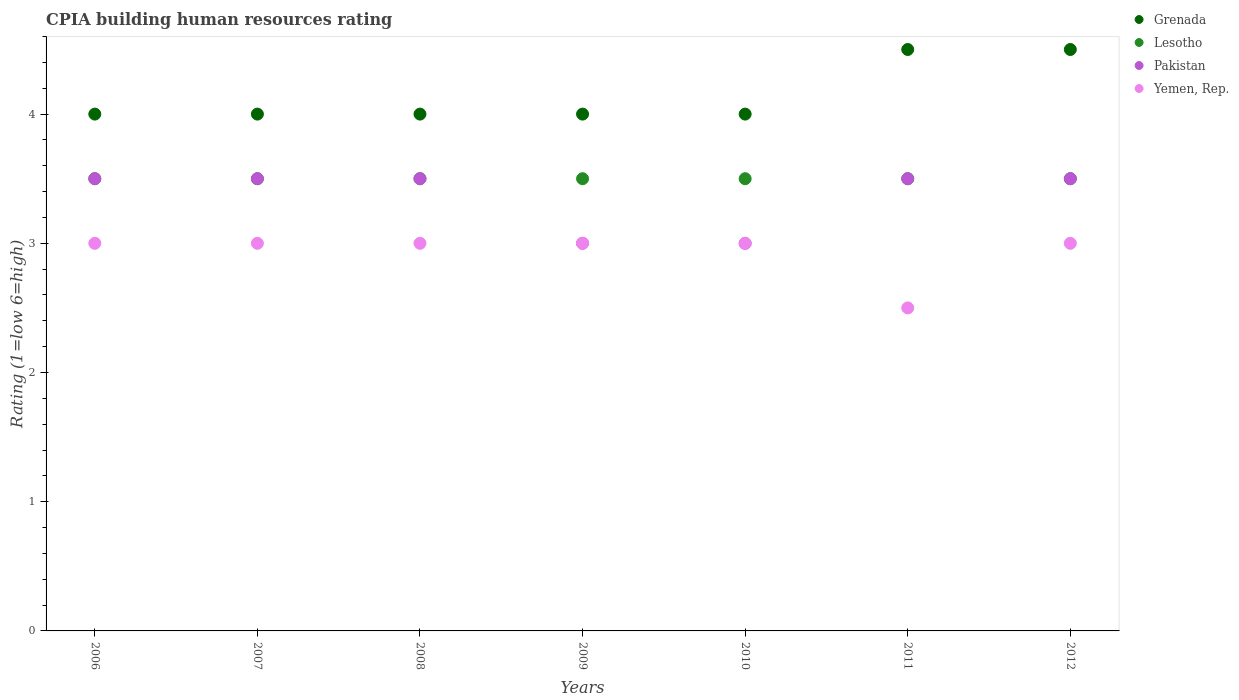How many different coloured dotlines are there?
Your answer should be very brief. 4. Across all years, what is the maximum CPIA rating in Grenada?
Keep it short and to the point. 4.5. In which year was the CPIA rating in Pakistan minimum?
Offer a very short reply. 2009. What is the total CPIA rating in Yemen, Rep. in the graph?
Your answer should be very brief. 20.5. What is the difference between the CPIA rating in Yemen, Rep. in 2009 and that in 2011?
Your answer should be compact. 0.5. What is the average CPIA rating in Pakistan per year?
Your answer should be very brief. 3.36. In the year 2010, what is the difference between the CPIA rating in Lesotho and CPIA rating in Grenada?
Give a very brief answer. -0.5. In how many years, is the CPIA rating in Lesotho greater than 4.4?
Keep it short and to the point. 0. What is the ratio of the CPIA rating in Pakistan in 2006 to that in 2007?
Provide a succinct answer. 1. Is the difference between the CPIA rating in Lesotho in 2008 and 2009 greater than the difference between the CPIA rating in Grenada in 2008 and 2009?
Your response must be concise. No. What is the difference between the highest and the second highest CPIA rating in Grenada?
Your answer should be very brief. 0. What is the difference between the highest and the lowest CPIA rating in Yemen, Rep.?
Give a very brief answer. 0.5. In how many years, is the CPIA rating in Yemen, Rep. greater than the average CPIA rating in Yemen, Rep. taken over all years?
Your answer should be very brief. 6. Is it the case that in every year, the sum of the CPIA rating in Lesotho and CPIA rating in Yemen, Rep.  is greater than the sum of CPIA rating in Grenada and CPIA rating in Pakistan?
Provide a succinct answer. No. Is it the case that in every year, the sum of the CPIA rating in Yemen, Rep. and CPIA rating in Lesotho  is greater than the CPIA rating in Pakistan?
Ensure brevity in your answer.  Yes. How many dotlines are there?
Provide a short and direct response. 4. What is the difference between two consecutive major ticks on the Y-axis?
Ensure brevity in your answer.  1. Are the values on the major ticks of Y-axis written in scientific E-notation?
Offer a terse response. No. Does the graph contain any zero values?
Ensure brevity in your answer.  No. Where does the legend appear in the graph?
Your response must be concise. Top right. How are the legend labels stacked?
Offer a terse response. Vertical. What is the title of the graph?
Provide a succinct answer. CPIA building human resources rating. Does "Montenegro" appear as one of the legend labels in the graph?
Keep it short and to the point. No. What is the label or title of the X-axis?
Your answer should be very brief. Years. What is the label or title of the Y-axis?
Your response must be concise. Rating (1=low 6=high). What is the Rating (1=low 6=high) of Pakistan in 2007?
Your response must be concise. 3.5. What is the Rating (1=low 6=high) in Lesotho in 2008?
Ensure brevity in your answer.  3.5. What is the Rating (1=low 6=high) of Pakistan in 2008?
Make the answer very short. 3.5. What is the Rating (1=low 6=high) in Grenada in 2009?
Your answer should be very brief. 4. What is the Rating (1=low 6=high) in Grenada in 2010?
Offer a terse response. 4. What is the Rating (1=low 6=high) of Yemen, Rep. in 2011?
Offer a very short reply. 2.5. What is the Rating (1=low 6=high) of Lesotho in 2012?
Offer a very short reply. 3.5. What is the Rating (1=low 6=high) of Yemen, Rep. in 2012?
Provide a succinct answer. 3. Across all years, what is the maximum Rating (1=low 6=high) of Lesotho?
Offer a very short reply. 3.5. Across all years, what is the minimum Rating (1=low 6=high) in Lesotho?
Keep it short and to the point. 3.5. Across all years, what is the minimum Rating (1=low 6=high) of Yemen, Rep.?
Offer a terse response. 2.5. What is the total Rating (1=low 6=high) in Grenada in the graph?
Ensure brevity in your answer.  29. What is the total Rating (1=low 6=high) of Pakistan in the graph?
Your response must be concise. 23.5. What is the difference between the Rating (1=low 6=high) of Lesotho in 2006 and that in 2007?
Offer a terse response. 0. What is the difference between the Rating (1=low 6=high) in Grenada in 2006 and that in 2008?
Your answer should be very brief. 0. What is the difference between the Rating (1=low 6=high) of Lesotho in 2006 and that in 2008?
Offer a very short reply. 0. What is the difference between the Rating (1=low 6=high) in Pakistan in 2006 and that in 2008?
Provide a succinct answer. 0. What is the difference between the Rating (1=low 6=high) in Lesotho in 2006 and that in 2009?
Offer a terse response. 0. What is the difference between the Rating (1=low 6=high) in Pakistan in 2006 and that in 2009?
Your answer should be very brief. 0.5. What is the difference between the Rating (1=low 6=high) of Yemen, Rep. in 2006 and that in 2009?
Offer a very short reply. 0. What is the difference between the Rating (1=low 6=high) of Lesotho in 2006 and that in 2010?
Your answer should be very brief. 0. What is the difference between the Rating (1=low 6=high) in Pakistan in 2006 and that in 2010?
Your answer should be compact. 0.5. What is the difference between the Rating (1=low 6=high) in Pakistan in 2006 and that in 2011?
Offer a very short reply. 0. What is the difference between the Rating (1=low 6=high) of Lesotho in 2006 and that in 2012?
Provide a succinct answer. 0. What is the difference between the Rating (1=low 6=high) of Pakistan in 2007 and that in 2008?
Your answer should be very brief. 0. What is the difference between the Rating (1=low 6=high) of Yemen, Rep. in 2007 and that in 2008?
Ensure brevity in your answer.  0. What is the difference between the Rating (1=low 6=high) of Yemen, Rep. in 2007 and that in 2010?
Keep it short and to the point. 0. What is the difference between the Rating (1=low 6=high) of Grenada in 2007 and that in 2011?
Provide a succinct answer. -0.5. What is the difference between the Rating (1=low 6=high) in Pakistan in 2007 and that in 2011?
Give a very brief answer. 0. What is the difference between the Rating (1=low 6=high) in Yemen, Rep. in 2007 and that in 2011?
Offer a terse response. 0.5. What is the difference between the Rating (1=low 6=high) of Grenada in 2007 and that in 2012?
Offer a terse response. -0.5. What is the difference between the Rating (1=low 6=high) of Lesotho in 2007 and that in 2012?
Offer a terse response. 0. What is the difference between the Rating (1=low 6=high) in Grenada in 2008 and that in 2009?
Your answer should be compact. 0. What is the difference between the Rating (1=low 6=high) in Pakistan in 2008 and that in 2011?
Provide a short and direct response. 0. What is the difference between the Rating (1=low 6=high) of Yemen, Rep. in 2008 and that in 2011?
Ensure brevity in your answer.  0.5. What is the difference between the Rating (1=low 6=high) in Lesotho in 2008 and that in 2012?
Keep it short and to the point. 0. What is the difference between the Rating (1=low 6=high) in Pakistan in 2008 and that in 2012?
Offer a very short reply. 0. What is the difference between the Rating (1=low 6=high) in Grenada in 2009 and that in 2010?
Offer a terse response. 0. What is the difference between the Rating (1=low 6=high) of Grenada in 2009 and that in 2011?
Provide a succinct answer. -0.5. What is the difference between the Rating (1=low 6=high) in Grenada in 2009 and that in 2012?
Offer a terse response. -0.5. What is the difference between the Rating (1=low 6=high) in Grenada in 2010 and that in 2011?
Provide a short and direct response. -0.5. What is the difference between the Rating (1=low 6=high) of Lesotho in 2010 and that in 2011?
Offer a very short reply. 0. What is the difference between the Rating (1=low 6=high) of Pakistan in 2010 and that in 2011?
Keep it short and to the point. -0.5. What is the difference between the Rating (1=low 6=high) in Yemen, Rep. in 2010 and that in 2011?
Offer a very short reply. 0.5. What is the difference between the Rating (1=low 6=high) in Grenada in 2010 and that in 2012?
Offer a very short reply. -0.5. What is the difference between the Rating (1=low 6=high) in Pakistan in 2010 and that in 2012?
Your answer should be compact. -0.5. What is the difference between the Rating (1=low 6=high) in Lesotho in 2011 and that in 2012?
Your answer should be compact. 0. What is the difference between the Rating (1=low 6=high) of Yemen, Rep. in 2011 and that in 2012?
Keep it short and to the point. -0.5. What is the difference between the Rating (1=low 6=high) of Grenada in 2006 and the Rating (1=low 6=high) of Lesotho in 2007?
Provide a succinct answer. 0.5. What is the difference between the Rating (1=low 6=high) in Lesotho in 2006 and the Rating (1=low 6=high) in Yemen, Rep. in 2007?
Make the answer very short. 0.5. What is the difference between the Rating (1=low 6=high) in Pakistan in 2006 and the Rating (1=low 6=high) in Yemen, Rep. in 2007?
Provide a succinct answer. 0.5. What is the difference between the Rating (1=low 6=high) of Grenada in 2006 and the Rating (1=low 6=high) of Lesotho in 2008?
Offer a terse response. 0.5. What is the difference between the Rating (1=low 6=high) of Lesotho in 2006 and the Rating (1=low 6=high) of Pakistan in 2008?
Ensure brevity in your answer.  0. What is the difference between the Rating (1=low 6=high) of Lesotho in 2006 and the Rating (1=low 6=high) of Yemen, Rep. in 2008?
Your answer should be very brief. 0.5. What is the difference between the Rating (1=low 6=high) in Pakistan in 2006 and the Rating (1=low 6=high) in Yemen, Rep. in 2008?
Your answer should be very brief. 0.5. What is the difference between the Rating (1=low 6=high) of Lesotho in 2006 and the Rating (1=low 6=high) of Pakistan in 2009?
Your answer should be very brief. 0.5. What is the difference between the Rating (1=low 6=high) of Grenada in 2006 and the Rating (1=low 6=high) of Lesotho in 2010?
Your response must be concise. 0.5. What is the difference between the Rating (1=low 6=high) in Lesotho in 2006 and the Rating (1=low 6=high) in Yemen, Rep. in 2010?
Offer a terse response. 0.5. What is the difference between the Rating (1=low 6=high) of Lesotho in 2006 and the Rating (1=low 6=high) of Yemen, Rep. in 2011?
Keep it short and to the point. 1. What is the difference between the Rating (1=low 6=high) of Grenada in 2006 and the Rating (1=low 6=high) of Pakistan in 2012?
Your answer should be compact. 0.5. What is the difference between the Rating (1=low 6=high) of Lesotho in 2006 and the Rating (1=low 6=high) of Pakistan in 2012?
Offer a terse response. 0. What is the difference between the Rating (1=low 6=high) of Lesotho in 2006 and the Rating (1=low 6=high) of Yemen, Rep. in 2012?
Provide a short and direct response. 0.5. What is the difference between the Rating (1=low 6=high) in Pakistan in 2006 and the Rating (1=low 6=high) in Yemen, Rep. in 2012?
Provide a succinct answer. 0.5. What is the difference between the Rating (1=low 6=high) in Grenada in 2007 and the Rating (1=low 6=high) in Pakistan in 2008?
Keep it short and to the point. 0.5. What is the difference between the Rating (1=low 6=high) of Grenada in 2007 and the Rating (1=low 6=high) of Yemen, Rep. in 2008?
Give a very brief answer. 1. What is the difference between the Rating (1=low 6=high) of Grenada in 2007 and the Rating (1=low 6=high) of Lesotho in 2009?
Give a very brief answer. 0.5. What is the difference between the Rating (1=low 6=high) in Grenada in 2007 and the Rating (1=low 6=high) in Yemen, Rep. in 2009?
Your answer should be compact. 1. What is the difference between the Rating (1=low 6=high) of Lesotho in 2007 and the Rating (1=low 6=high) of Pakistan in 2009?
Offer a terse response. 0.5. What is the difference between the Rating (1=low 6=high) in Lesotho in 2007 and the Rating (1=low 6=high) in Yemen, Rep. in 2009?
Offer a terse response. 0.5. What is the difference between the Rating (1=low 6=high) in Pakistan in 2007 and the Rating (1=low 6=high) in Yemen, Rep. in 2009?
Your answer should be compact. 0.5. What is the difference between the Rating (1=low 6=high) in Grenada in 2007 and the Rating (1=low 6=high) in Lesotho in 2010?
Provide a succinct answer. 0.5. What is the difference between the Rating (1=low 6=high) of Grenada in 2007 and the Rating (1=low 6=high) of Pakistan in 2010?
Your answer should be very brief. 1. What is the difference between the Rating (1=low 6=high) in Lesotho in 2007 and the Rating (1=low 6=high) in Pakistan in 2010?
Offer a terse response. 0.5. What is the difference between the Rating (1=low 6=high) in Grenada in 2007 and the Rating (1=low 6=high) in Lesotho in 2011?
Offer a terse response. 0.5. What is the difference between the Rating (1=low 6=high) of Grenada in 2007 and the Rating (1=low 6=high) of Pakistan in 2011?
Your answer should be very brief. 0.5. What is the difference between the Rating (1=low 6=high) in Lesotho in 2007 and the Rating (1=low 6=high) in Yemen, Rep. in 2011?
Provide a short and direct response. 1. What is the difference between the Rating (1=low 6=high) in Pakistan in 2007 and the Rating (1=low 6=high) in Yemen, Rep. in 2011?
Ensure brevity in your answer.  1. What is the difference between the Rating (1=low 6=high) of Grenada in 2007 and the Rating (1=low 6=high) of Lesotho in 2012?
Your answer should be compact. 0.5. What is the difference between the Rating (1=low 6=high) in Grenada in 2007 and the Rating (1=low 6=high) in Pakistan in 2012?
Give a very brief answer. 0.5. What is the difference between the Rating (1=low 6=high) of Lesotho in 2007 and the Rating (1=low 6=high) of Pakistan in 2012?
Offer a very short reply. 0. What is the difference between the Rating (1=low 6=high) in Lesotho in 2007 and the Rating (1=low 6=high) in Yemen, Rep. in 2012?
Make the answer very short. 0.5. What is the difference between the Rating (1=low 6=high) in Pakistan in 2007 and the Rating (1=low 6=high) in Yemen, Rep. in 2012?
Provide a short and direct response. 0.5. What is the difference between the Rating (1=low 6=high) of Grenada in 2008 and the Rating (1=low 6=high) of Pakistan in 2009?
Offer a terse response. 1. What is the difference between the Rating (1=low 6=high) of Lesotho in 2008 and the Rating (1=low 6=high) of Yemen, Rep. in 2010?
Give a very brief answer. 0.5. What is the difference between the Rating (1=low 6=high) in Pakistan in 2008 and the Rating (1=low 6=high) in Yemen, Rep. in 2010?
Offer a very short reply. 0.5. What is the difference between the Rating (1=low 6=high) in Grenada in 2008 and the Rating (1=low 6=high) in Pakistan in 2011?
Make the answer very short. 0.5. What is the difference between the Rating (1=low 6=high) of Grenada in 2008 and the Rating (1=low 6=high) of Lesotho in 2012?
Offer a terse response. 0.5. What is the difference between the Rating (1=low 6=high) of Grenada in 2008 and the Rating (1=low 6=high) of Pakistan in 2012?
Keep it short and to the point. 0.5. What is the difference between the Rating (1=low 6=high) of Grenada in 2008 and the Rating (1=low 6=high) of Yemen, Rep. in 2012?
Offer a terse response. 1. What is the difference between the Rating (1=low 6=high) of Lesotho in 2008 and the Rating (1=low 6=high) of Pakistan in 2012?
Keep it short and to the point. 0. What is the difference between the Rating (1=low 6=high) in Lesotho in 2008 and the Rating (1=low 6=high) in Yemen, Rep. in 2012?
Ensure brevity in your answer.  0.5. What is the difference between the Rating (1=low 6=high) of Pakistan in 2008 and the Rating (1=low 6=high) of Yemen, Rep. in 2012?
Provide a short and direct response. 0.5. What is the difference between the Rating (1=low 6=high) of Grenada in 2009 and the Rating (1=low 6=high) of Pakistan in 2010?
Give a very brief answer. 1. What is the difference between the Rating (1=low 6=high) of Lesotho in 2009 and the Rating (1=low 6=high) of Yemen, Rep. in 2010?
Provide a succinct answer. 0.5. What is the difference between the Rating (1=low 6=high) of Pakistan in 2009 and the Rating (1=low 6=high) of Yemen, Rep. in 2010?
Your answer should be compact. 0. What is the difference between the Rating (1=low 6=high) in Grenada in 2009 and the Rating (1=low 6=high) in Lesotho in 2011?
Your answer should be compact. 0.5. What is the difference between the Rating (1=low 6=high) in Grenada in 2009 and the Rating (1=low 6=high) in Pakistan in 2011?
Provide a short and direct response. 0.5. What is the difference between the Rating (1=low 6=high) in Grenada in 2009 and the Rating (1=low 6=high) in Yemen, Rep. in 2011?
Your response must be concise. 1.5. What is the difference between the Rating (1=low 6=high) of Lesotho in 2009 and the Rating (1=low 6=high) of Pakistan in 2011?
Make the answer very short. 0. What is the difference between the Rating (1=low 6=high) of Lesotho in 2009 and the Rating (1=low 6=high) of Yemen, Rep. in 2011?
Your answer should be very brief. 1. What is the difference between the Rating (1=low 6=high) of Pakistan in 2009 and the Rating (1=low 6=high) of Yemen, Rep. in 2011?
Ensure brevity in your answer.  0.5. What is the difference between the Rating (1=low 6=high) of Grenada in 2009 and the Rating (1=low 6=high) of Lesotho in 2012?
Provide a short and direct response. 0.5. What is the difference between the Rating (1=low 6=high) of Lesotho in 2009 and the Rating (1=low 6=high) of Yemen, Rep. in 2012?
Make the answer very short. 0.5. What is the difference between the Rating (1=low 6=high) in Grenada in 2010 and the Rating (1=low 6=high) in Pakistan in 2011?
Make the answer very short. 0.5. What is the difference between the Rating (1=low 6=high) in Lesotho in 2010 and the Rating (1=low 6=high) in Pakistan in 2011?
Provide a short and direct response. 0. What is the difference between the Rating (1=low 6=high) in Grenada in 2010 and the Rating (1=low 6=high) in Lesotho in 2012?
Give a very brief answer. 0.5. What is the difference between the Rating (1=low 6=high) of Grenada in 2010 and the Rating (1=low 6=high) of Yemen, Rep. in 2012?
Ensure brevity in your answer.  1. What is the difference between the Rating (1=low 6=high) of Grenada in 2011 and the Rating (1=low 6=high) of Lesotho in 2012?
Give a very brief answer. 1. What is the difference between the Rating (1=low 6=high) in Grenada in 2011 and the Rating (1=low 6=high) in Yemen, Rep. in 2012?
Ensure brevity in your answer.  1.5. What is the difference between the Rating (1=low 6=high) of Lesotho in 2011 and the Rating (1=low 6=high) of Pakistan in 2012?
Keep it short and to the point. 0. What is the average Rating (1=low 6=high) of Grenada per year?
Your response must be concise. 4.14. What is the average Rating (1=low 6=high) of Pakistan per year?
Make the answer very short. 3.36. What is the average Rating (1=low 6=high) in Yemen, Rep. per year?
Your response must be concise. 2.93. In the year 2006, what is the difference between the Rating (1=low 6=high) of Grenada and Rating (1=low 6=high) of Lesotho?
Your response must be concise. 0.5. In the year 2006, what is the difference between the Rating (1=low 6=high) in Lesotho and Rating (1=low 6=high) in Pakistan?
Offer a terse response. 0. In the year 2006, what is the difference between the Rating (1=low 6=high) of Pakistan and Rating (1=low 6=high) of Yemen, Rep.?
Give a very brief answer. 0.5. In the year 2007, what is the difference between the Rating (1=low 6=high) in Grenada and Rating (1=low 6=high) in Lesotho?
Ensure brevity in your answer.  0.5. In the year 2007, what is the difference between the Rating (1=low 6=high) of Grenada and Rating (1=low 6=high) of Pakistan?
Your answer should be compact. 0.5. In the year 2007, what is the difference between the Rating (1=low 6=high) in Lesotho and Rating (1=low 6=high) in Pakistan?
Make the answer very short. 0. In the year 2007, what is the difference between the Rating (1=low 6=high) of Lesotho and Rating (1=low 6=high) of Yemen, Rep.?
Provide a short and direct response. 0.5. In the year 2007, what is the difference between the Rating (1=low 6=high) in Pakistan and Rating (1=low 6=high) in Yemen, Rep.?
Ensure brevity in your answer.  0.5. In the year 2008, what is the difference between the Rating (1=low 6=high) of Lesotho and Rating (1=low 6=high) of Pakistan?
Offer a terse response. 0. In the year 2008, what is the difference between the Rating (1=low 6=high) of Lesotho and Rating (1=low 6=high) of Yemen, Rep.?
Your response must be concise. 0.5. In the year 2008, what is the difference between the Rating (1=low 6=high) in Pakistan and Rating (1=low 6=high) in Yemen, Rep.?
Provide a short and direct response. 0.5. In the year 2009, what is the difference between the Rating (1=low 6=high) of Grenada and Rating (1=low 6=high) of Yemen, Rep.?
Give a very brief answer. 1. In the year 2010, what is the difference between the Rating (1=low 6=high) in Grenada and Rating (1=low 6=high) in Lesotho?
Your answer should be compact. 0.5. In the year 2010, what is the difference between the Rating (1=low 6=high) in Lesotho and Rating (1=low 6=high) in Pakistan?
Offer a terse response. 0.5. In the year 2010, what is the difference between the Rating (1=low 6=high) in Lesotho and Rating (1=low 6=high) in Yemen, Rep.?
Provide a short and direct response. 0.5. In the year 2010, what is the difference between the Rating (1=low 6=high) in Pakistan and Rating (1=low 6=high) in Yemen, Rep.?
Ensure brevity in your answer.  0. In the year 2011, what is the difference between the Rating (1=low 6=high) in Grenada and Rating (1=low 6=high) in Pakistan?
Your answer should be very brief. 1. In the year 2011, what is the difference between the Rating (1=low 6=high) in Grenada and Rating (1=low 6=high) in Yemen, Rep.?
Make the answer very short. 2. In the year 2011, what is the difference between the Rating (1=low 6=high) of Lesotho and Rating (1=low 6=high) of Yemen, Rep.?
Your response must be concise. 1. In the year 2011, what is the difference between the Rating (1=low 6=high) of Pakistan and Rating (1=low 6=high) of Yemen, Rep.?
Make the answer very short. 1. In the year 2012, what is the difference between the Rating (1=low 6=high) of Grenada and Rating (1=low 6=high) of Pakistan?
Keep it short and to the point. 1. In the year 2012, what is the difference between the Rating (1=low 6=high) in Grenada and Rating (1=low 6=high) in Yemen, Rep.?
Ensure brevity in your answer.  1.5. What is the ratio of the Rating (1=low 6=high) in Lesotho in 2006 to that in 2007?
Your answer should be very brief. 1. What is the ratio of the Rating (1=low 6=high) of Lesotho in 2006 to that in 2008?
Your response must be concise. 1. What is the ratio of the Rating (1=low 6=high) of Yemen, Rep. in 2006 to that in 2008?
Provide a succinct answer. 1. What is the ratio of the Rating (1=low 6=high) of Grenada in 2006 to that in 2009?
Your answer should be very brief. 1. What is the ratio of the Rating (1=low 6=high) of Lesotho in 2006 to that in 2009?
Make the answer very short. 1. What is the ratio of the Rating (1=low 6=high) of Yemen, Rep. in 2006 to that in 2009?
Provide a succinct answer. 1. What is the ratio of the Rating (1=low 6=high) of Grenada in 2006 to that in 2010?
Provide a succinct answer. 1. What is the ratio of the Rating (1=low 6=high) of Pakistan in 2006 to that in 2010?
Your response must be concise. 1.17. What is the ratio of the Rating (1=low 6=high) of Yemen, Rep. in 2006 to that in 2010?
Make the answer very short. 1. What is the ratio of the Rating (1=low 6=high) of Lesotho in 2006 to that in 2011?
Ensure brevity in your answer.  1. What is the ratio of the Rating (1=low 6=high) of Grenada in 2006 to that in 2012?
Offer a very short reply. 0.89. What is the ratio of the Rating (1=low 6=high) in Pakistan in 2006 to that in 2012?
Ensure brevity in your answer.  1. What is the ratio of the Rating (1=low 6=high) of Yemen, Rep. in 2006 to that in 2012?
Give a very brief answer. 1. What is the ratio of the Rating (1=low 6=high) of Lesotho in 2007 to that in 2008?
Offer a very short reply. 1. What is the ratio of the Rating (1=low 6=high) of Pakistan in 2007 to that in 2008?
Provide a short and direct response. 1. What is the ratio of the Rating (1=low 6=high) of Yemen, Rep. in 2007 to that in 2008?
Your answer should be compact. 1. What is the ratio of the Rating (1=low 6=high) of Lesotho in 2007 to that in 2009?
Offer a very short reply. 1. What is the ratio of the Rating (1=low 6=high) of Pakistan in 2007 to that in 2009?
Ensure brevity in your answer.  1.17. What is the ratio of the Rating (1=low 6=high) of Yemen, Rep. in 2007 to that in 2009?
Ensure brevity in your answer.  1. What is the ratio of the Rating (1=low 6=high) in Lesotho in 2007 to that in 2010?
Offer a very short reply. 1. What is the ratio of the Rating (1=low 6=high) in Lesotho in 2007 to that in 2011?
Offer a terse response. 1. What is the ratio of the Rating (1=low 6=high) of Pakistan in 2007 to that in 2011?
Offer a very short reply. 1. What is the ratio of the Rating (1=low 6=high) in Yemen, Rep. in 2007 to that in 2011?
Your answer should be very brief. 1.2. What is the ratio of the Rating (1=low 6=high) of Grenada in 2007 to that in 2012?
Your answer should be compact. 0.89. What is the ratio of the Rating (1=low 6=high) of Pakistan in 2007 to that in 2012?
Keep it short and to the point. 1. What is the ratio of the Rating (1=low 6=high) in Lesotho in 2008 to that in 2009?
Provide a short and direct response. 1. What is the ratio of the Rating (1=low 6=high) in Yemen, Rep. in 2008 to that in 2009?
Your response must be concise. 1. What is the ratio of the Rating (1=low 6=high) of Lesotho in 2008 to that in 2010?
Your answer should be compact. 1. What is the ratio of the Rating (1=low 6=high) in Yemen, Rep. in 2008 to that in 2010?
Keep it short and to the point. 1. What is the ratio of the Rating (1=low 6=high) of Lesotho in 2008 to that in 2011?
Make the answer very short. 1. What is the ratio of the Rating (1=low 6=high) in Pakistan in 2008 to that in 2011?
Offer a terse response. 1. What is the ratio of the Rating (1=low 6=high) of Yemen, Rep. in 2008 to that in 2011?
Provide a short and direct response. 1.2. What is the ratio of the Rating (1=low 6=high) of Grenada in 2008 to that in 2012?
Your response must be concise. 0.89. What is the ratio of the Rating (1=low 6=high) in Lesotho in 2008 to that in 2012?
Keep it short and to the point. 1. What is the ratio of the Rating (1=low 6=high) of Yemen, Rep. in 2008 to that in 2012?
Provide a short and direct response. 1. What is the ratio of the Rating (1=low 6=high) of Grenada in 2009 to that in 2010?
Provide a short and direct response. 1. What is the ratio of the Rating (1=low 6=high) of Pakistan in 2009 to that in 2010?
Provide a succinct answer. 1. What is the ratio of the Rating (1=low 6=high) of Pakistan in 2009 to that in 2012?
Offer a terse response. 0.86. What is the ratio of the Rating (1=low 6=high) of Lesotho in 2010 to that in 2011?
Your answer should be very brief. 1. What is the ratio of the Rating (1=low 6=high) in Pakistan in 2010 to that in 2011?
Ensure brevity in your answer.  0.86. What is the ratio of the Rating (1=low 6=high) in Yemen, Rep. in 2010 to that in 2011?
Ensure brevity in your answer.  1.2. What is the ratio of the Rating (1=low 6=high) in Grenada in 2010 to that in 2012?
Your answer should be compact. 0.89. What is the ratio of the Rating (1=low 6=high) of Lesotho in 2010 to that in 2012?
Provide a short and direct response. 1. What is the ratio of the Rating (1=low 6=high) in Grenada in 2011 to that in 2012?
Your answer should be very brief. 1. What is the ratio of the Rating (1=low 6=high) of Yemen, Rep. in 2011 to that in 2012?
Provide a short and direct response. 0.83. What is the difference between the highest and the lowest Rating (1=low 6=high) of Grenada?
Ensure brevity in your answer.  0.5. What is the difference between the highest and the lowest Rating (1=low 6=high) of Lesotho?
Offer a terse response. 0. What is the difference between the highest and the lowest Rating (1=low 6=high) of Pakistan?
Offer a terse response. 0.5. 